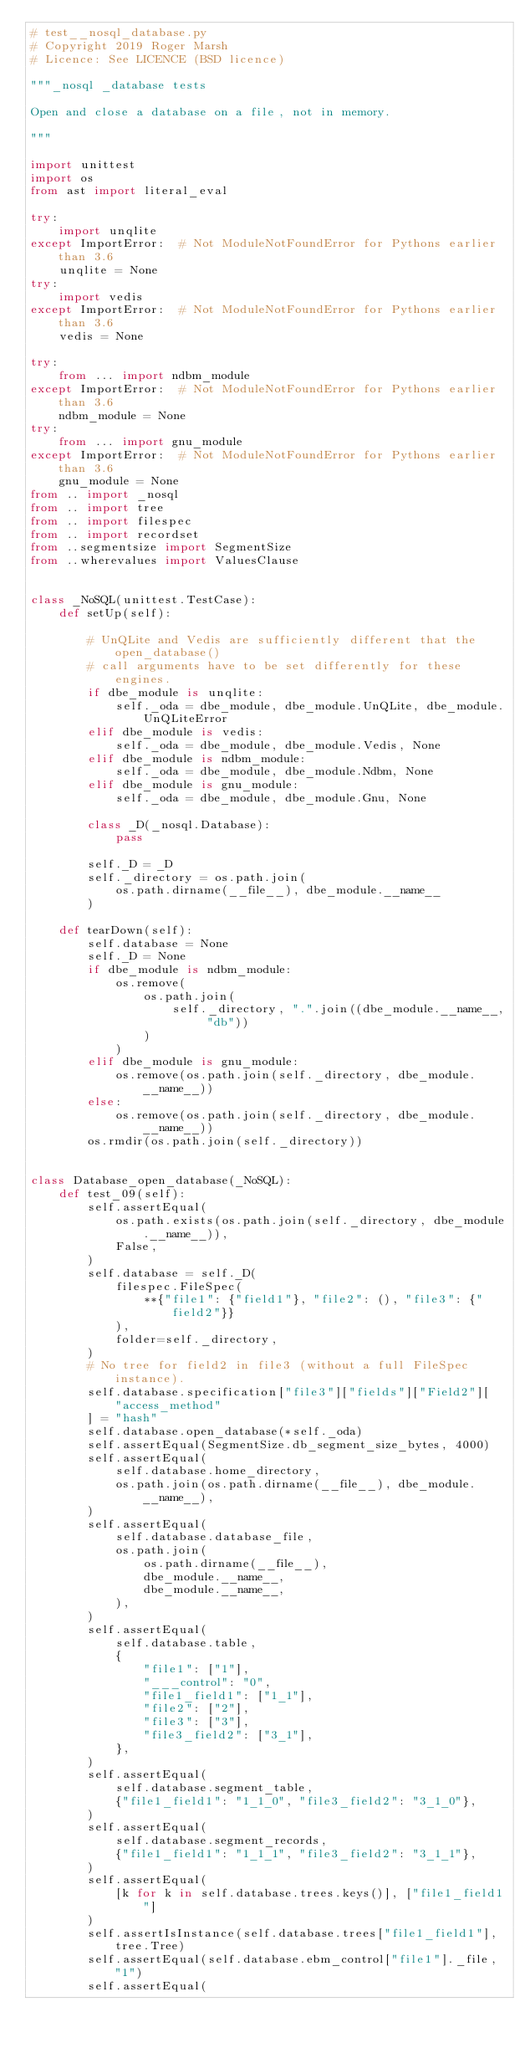Convert code to text. <code><loc_0><loc_0><loc_500><loc_500><_Python_># test__nosql_database.py
# Copyright 2019 Roger Marsh
# Licence: See LICENCE (BSD licence)

"""_nosql _database tests

Open and close a database on a file, not in memory.

"""

import unittest
import os
from ast import literal_eval

try:
    import unqlite
except ImportError:  # Not ModuleNotFoundError for Pythons earlier than 3.6
    unqlite = None
try:
    import vedis
except ImportError:  # Not ModuleNotFoundError for Pythons earlier than 3.6
    vedis = None

try:
    from ... import ndbm_module
except ImportError:  # Not ModuleNotFoundError for Pythons earlier than 3.6
    ndbm_module = None
try:
    from ... import gnu_module
except ImportError:  # Not ModuleNotFoundError for Pythons earlier than 3.6
    gnu_module = None
from .. import _nosql
from .. import tree
from .. import filespec
from .. import recordset
from ..segmentsize import SegmentSize
from ..wherevalues import ValuesClause


class _NoSQL(unittest.TestCase):
    def setUp(self):

        # UnQLite and Vedis are sufficiently different that the open_database()
        # call arguments have to be set differently for these engines.
        if dbe_module is unqlite:
            self._oda = dbe_module, dbe_module.UnQLite, dbe_module.UnQLiteError
        elif dbe_module is vedis:
            self._oda = dbe_module, dbe_module.Vedis, None
        elif dbe_module is ndbm_module:
            self._oda = dbe_module, dbe_module.Ndbm, None
        elif dbe_module is gnu_module:
            self._oda = dbe_module, dbe_module.Gnu, None

        class _D(_nosql.Database):
            pass

        self._D = _D
        self._directory = os.path.join(
            os.path.dirname(__file__), dbe_module.__name__
        )

    def tearDown(self):
        self.database = None
        self._D = None
        if dbe_module is ndbm_module:
            os.remove(
                os.path.join(
                    self._directory, ".".join((dbe_module.__name__, "db"))
                )
            )
        elif dbe_module is gnu_module:
            os.remove(os.path.join(self._directory, dbe_module.__name__))
        else:
            os.remove(os.path.join(self._directory, dbe_module.__name__))
        os.rmdir(os.path.join(self._directory))


class Database_open_database(_NoSQL):
    def test_09(self):
        self.assertEqual(
            os.path.exists(os.path.join(self._directory, dbe_module.__name__)),
            False,
        )
        self.database = self._D(
            filespec.FileSpec(
                **{"file1": {"field1"}, "file2": (), "file3": {"field2"}}
            ),
            folder=self._directory,
        )
        # No tree for field2 in file3 (without a full FileSpec instance).
        self.database.specification["file3"]["fields"]["Field2"][
            "access_method"
        ] = "hash"
        self.database.open_database(*self._oda)
        self.assertEqual(SegmentSize.db_segment_size_bytes, 4000)
        self.assertEqual(
            self.database.home_directory,
            os.path.join(os.path.dirname(__file__), dbe_module.__name__),
        )
        self.assertEqual(
            self.database.database_file,
            os.path.join(
                os.path.dirname(__file__),
                dbe_module.__name__,
                dbe_module.__name__,
            ),
        )
        self.assertEqual(
            self.database.table,
            {
                "file1": ["1"],
                "___control": "0",
                "file1_field1": ["1_1"],
                "file2": ["2"],
                "file3": ["3"],
                "file3_field2": ["3_1"],
            },
        )
        self.assertEqual(
            self.database.segment_table,
            {"file1_field1": "1_1_0", "file3_field2": "3_1_0"},
        )
        self.assertEqual(
            self.database.segment_records,
            {"file1_field1": "1_1_1", "file3_field2": "3_1_1"},
        )
        self.assertEqual(
            [k for k in self.database.trees.keys()], ["file1_field1"]
        )
        self.assertIsInstance(self.database.trees["file1_field1"], tree.Tree)
        self.assertEqual(self.database.ebm_control["file1"]._file, "1")
        self.assertEqual(</code> 